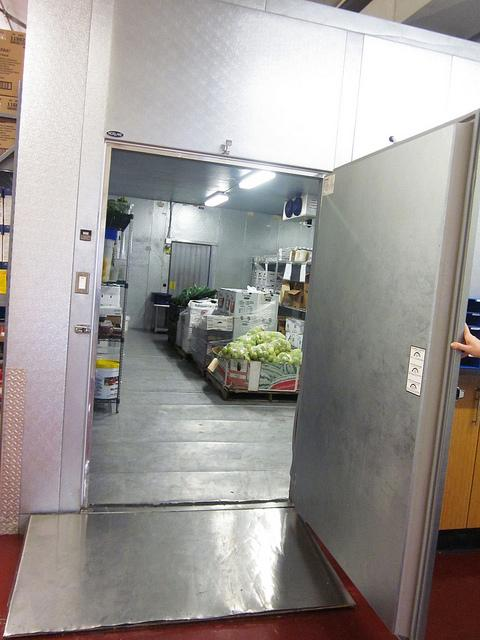What does this door lead to? Please explain your reasoning. walkin cooler. The door goes to a giant refrigerator. 